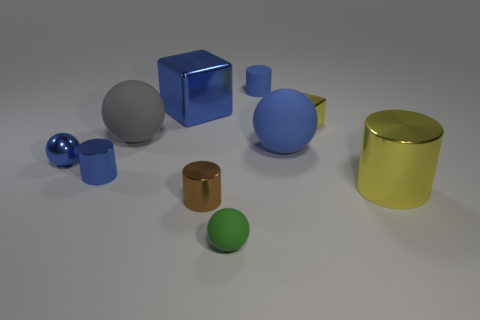Subtract all cylinders. How many objects are left? 6 Subtract all blue shiny things. Subtract all large cyan shiny cylinders. How many objects are left? 7 Add 1 big matte objects. How many big matte objects are left? 3 Add 8 tiny purple matte cubes. How many tiny purple matte cubes exist? 8 Subtract 0 red blocks. How many objects are left? 10 